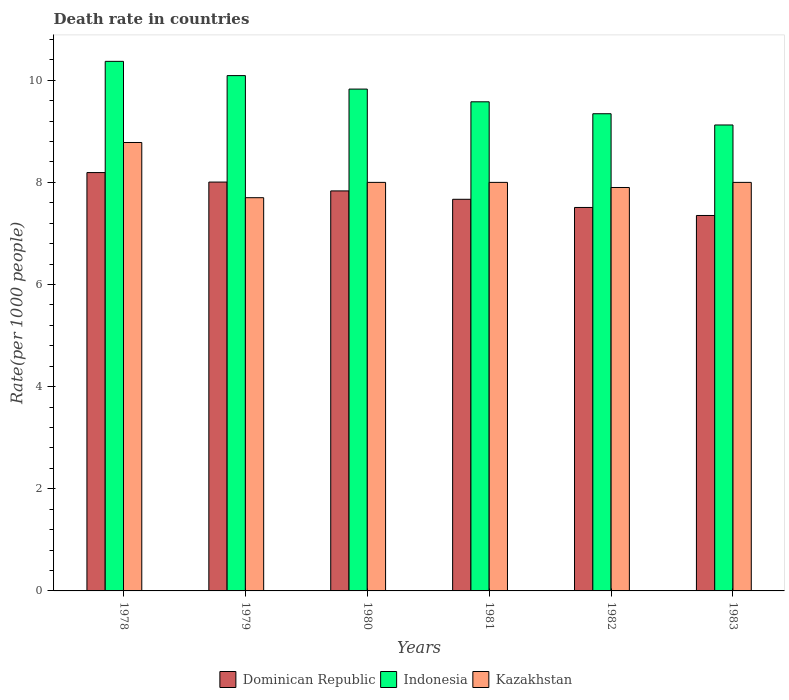How many different coloured bars are there?
Provide a short and direct response. 3. How many bars are there on the 2nd tick from the left?
Offer a very short reply. 3. What is the label of the 2nd group of bars from the left?
Provide a succinct answer. 1979. In how many cases, is the number of bars for a given year not equal to the number of legend labels?
Offer a terse response. 0. What is the death rate in Kazakhstan in 1980?
Offer a very short reply. 8. Across all years, what is the maximum death rate in Kazakhstan?
Make the answer very short. 8.78. In which year was the death rate in Indonesia maximum?
Your answer should be compact. 1978. What is the total death rate in Dominican Republic in the graph?
Your answer should be compact. 46.56. What is the difference between the death rate in Dominican Republic in 1980 and that in 1981?
Give a very brief answer. 0.16. What is the difference between the death rate in Dominican Republic in 1978 and the death rate in Kazakhstan in 1980?
Offer a terse response. 0.19. What is the average death rate in Dominican Republic per year?
Your response must be concise. 7.76. In the year 1981, what is the difference between the death rate in Dominican Republic and death rate in Indonesia?
Make the answer very short. -1.91. What is the ratio of the death rate in Kazakhstan in 1980 to that in 1981?
Make the answer very short. 1. Is the death rate in Dominican Republic in 1980 less than that in 1981?
Your response must be concise. No. Is the difference between the death rate in Dominican Republic in 1981 and 1983 greater than the difference between the death rate in Indonesia in 1981 and 1983?
Your response must be concise. No. What is the difference between the highest and the second highest death rate in Indonesia?
Provide a short and direct response. 0.28. What is the difference between the highest and the lowest death rate in Indonesia?
Provide a short and direct response. 1.25. What does the 3rd bar from the left in 1983 represents?
Offer a terse response. Kazakhstan. What does the 1st bar from the right in 1982 represents?
Your answer should be very brief. Kazakhstan. How many bars are there?
Your response must be concise. 18. Are all the bars in the graph horizontal?
Give a very brief answer. No. What is the difference between two consecutive major ticks on the Y-axis?
Ensure brevity in your answer.  2. Are the values on the major ticks of Y-axis written in scientific E-notation?
Your answer should be compact. No. Does the graph contain any zero values?
Ensure brevity in your answer.  No. Does the graph contain grids?
Give a very brief answer. No. How are the legend labels stacked?
Your response must be concise. Horizontal. What is the title of the graph?
Keep it short and to the point. Death rate in countries. What is the label or title of the Y-axis?
Give a very brief answer. Rate(per 1000 people). What is the Rate(per 1000 people) of Dominican Republic in 1978?
Ensure brevity in your answer.  8.19. What is the Rate(per 1000 people) in Indonesia in 1978?
Make the answer very short. 10.37. What is the Rate(per 1000 people) in Kazakhstan in 1978?
Provide a succinct answer. 8.78. What is the Rate(per 1000 people) in Dominican Republic in 1979?
Offer a terse response. 8.01. What is the Rate(per 1000 people) of Indonesia in 1979?
Offer a very short reply. 10.09. What is the Rate(per 1000 people) of Dominican Republic in 1980?
Offer a terse response. 7.83. What is the Rate(per 1000 people) in Indonesia in 1980?
Give a very brief answer. 9.83. What is the Rate(per 1000 people) of Dominican Republic in 1981?
Provide a succinct answer. 7.67. What is the Rate(per 1000 people) of Indonesia in 1981?
Offer a terse response. 9.58. What is the Rate(per 1000 people) of Dominican Republic in 1982?
Provide a short and direct response. 7.51. What is the Rate(per 1000 people) of Indonesia in 1982?
Your answer should be compact. 9.34. What is the Rate(per 1000 people) in Kazakhstan in 1982?
Your answer should be compact. 7.9. What is the Rate(per 1000 people) of Dominican Republic in 1983?
Provide a succinct answer. 7.35. What is the Rate(per 1000 people) of Indonesia in 1983?
Offer a very short reply. 9.12. Across all years, what is the maximum Rate(per 1000 people) in Dominican Republic?
Give a very brief answer. 8.19. Across all years, what is the maximum Rate(per 1000 people) of Indonesia?
Offer a terse response. 10.37. Across all years, what is the maximum Rate(per 1000 people) of Kazakhstan?
Your answer should be very brief. 8.78. Across all years, what is the minimum Rate(per 1000 people) of Dominican Republic?
Provide a short and direct response. 7.35. Across all years, what is the minimum Rate(per 1000 people) in Indonesia?
Your answer should be very brief. 9.12. What is the total Rate(per 1000 people) in Dominican Republic in the graph?
Provide a succinct answer. 46.56. What is the total Rate(per 1000 people) in Indonesia in the graph?
Provide a short and direct response. 58.33. What is the total Rate(per 1000 people) of Kazakhstan in the graph?
Provide a short and direct response. 48.38. What is the difference between the Rate(per 1000 people) of Dominican Republic in 1978 and that in 1979?
Give a very brief answer. 0.19. What is the difference between the Rate(per 1000 people) in Indonesia in 1978 and that in 1979?
Provide a short and direct response. 0.28. What is the difference between the Rate(per 1000 people) of Kazakhstan in 1978 and that in 1979?
Keep it short and to the point. 1.08. What is the difference between the Rate(per 1000 people) in Dominican Republic in 1978 and that in 1980?
Offer a terse response. 0.36. What is the difference between the Rate(per 1000 people) in Indonesia in 1978 and that in 1980?
Provide a succinct answer. 0.54. What is the difference between the Rate(per 1000 people) in Kazakhstan in 1978 and that in 1980?
Offer a terse response. 0.78. What is the difference between the Rate(per 1000 people) in Dominican Republic in 1978 and that in 1981?
Give a very brief answer. 0.52. What is the difference between the Rate(per 1000 people) of Indonesia in 1978 and that in 1981?
Your answer should be compact. 0.79. What is the difference between the Rate(per 1000 people) of Kazakhstan in 1978 and that in 1981?
Keep it short and to the point. 0.78. What is the difference between the Rate(per 1000 people) in Dominican Republic in 1978 and that in 1982?
Provide a short and direct response. 0.68. What is the difference between the Rate(per 1000 people) of Indonesia in 1978 and that in 1982?
Give a very brief answer. 1.03. What is the difference between the Rate(per 1000 people) in Kazakhstan in 1978 and that in 1982?
Keep it short and to the point. 0.88. What is the difference between the Rate(per 1000 people) of Dominican Republic in 1978 and that in 1983?
Keep it short and to the point. 0.84. What is the difference between the Rate(per 1000 people) of Indonesia in 1978 and that in 1983?
Provide a short and direct response. 1.25. What is the difference between the Rate(per 1000 people) of Kazakhstan in 1978 and that in 1983?
Offer a very short reply. 0.78. What is the difference between the Rate(per 1000 people) in Dominican Republic in 1979 and that in 1980?
Offer a terse response. 0.17. What is the difference between the Rate(per 1000 people) in Indonesia in 1979 and that in 1980?
Provide a short and direct response. 0.26. What is the difference between the Rate(per 1000 people) in Dominican Republic in 1979 and that in 1981?
Ensure brevity in your answer.  0.34. What is the difference between the Rate(per 1000 people) in Indonesia in 1979 and that in 1981?
Offer a terse response. 0.51. What is the difference between the Rate(per 1000 people) in Kazakhstan in 1979 and that in 1981?
Make the answer very short. -0.3. What is the difference between the Rate(per 1000 people) in Dominican Republic in 1979 and that in 1982?
Ensure brevity in your answer.  0.5. What is the difference between the Rate(per 1000 people) of Indonesia in 1979 and that in 1982?
Offer a very short reply. 0.75. What is the difference between the Rate(per 1000 people) of Dominican Republic in 1979 and that in 1983?
Make the answer very short. 0.65. What is the difference between the Rate(per 1000 people) of Indonesia in 1979 and that in 1983?
Your answer should be very brief. 0.97. What is the difference between the Rate(per 1000 people) in Kazakhstan in 1979 and that in 1983?
Offer a very short reply. -0.3. What is the difference between the Rate(per 1000 people) of Dominican Republic in 1980 and that in 1981?
Provide a short and direct response. 0.16. What is the difference between the Rate(per 1000 people) of Indonesia in 1980 and that in 1981?
Provide a succinct answer. 0.25. What is the difference between the Rate(per 1000 people) of Dominican Republic in 1980 and that in 1982?
Make the answer very short. 0.32. What is the difference between the Rate(per 1000 people) of Indonesia in 1980 and that in 1982?
Provide a succinct answer. 0.48. What is the difference between the Rate(per 1000 people) of Kazakhstan in 1980 and that in 1982?
Offer a very short reply. 0.1. What is the difference between the Rate(per 1000 people) of Dominican Republic in 1980 and that in 1983?
Offer a terse response. 0.48. What is the difference between the Rate(per 1000 people) of Indonesia in 1980 and that in 1983?
Ensure brevity in your answer.  0.7. What is the difference between the Rate(per 1000 people) of Kazakhstan in 1980 and that in 1983?
Offer a very short reply. 0. What is the difference between the Rate(per 1000 people) of Dominican Republic in 1981 and that in 1982?
Your answer should be compact. 0.16. What is the difference between the Rate(per 1000 people) in Indonesia in 1981 and that in 1982?
Give a very brief answer. 0.23. What is the difference between the Rate(per 1000 people) of Dominican Republic in 1981 and that in 1983?
Provide a short and direct response. 0.32. What is the difference between the Rate(per 1000 people) in Indonesia in 1981 and that in 1983?
Provide a short and direct response. 0.45. What is the difference between the Rate(per 1000 people) of Kazakhstan in 1981 and that in 1983?
Your answer should be very brief. 0. What is the difference between the Rate(per 1000 people) of Dominican Republic in 1982 and that in 1983?
Give a very brief answer. 0.16. What is the difference between the Rate(per 1000 people) of Indonesia in 1982 and that in 1983?
Provide a succinct answer. 0.22. What is the difference between the Rate(per 1000 people) in Kazakhstan in 1982 and that in 1983?
Offer a very short reply. -0.1. What is the difference between the Rate(per 1000 people) of Dominican Republic in 1978 and the Rate(per 1000 people) of Indonesia in 1979?
Ensure brevity in your answer.  -1.9. What is the difference between the Rate(per 1000 people) in Dominican Republic in 1978 and the Rate(per 1000 people) in Kazakhstan in 1979?
Your response must be concise. 0.49. What is the difference between the Rate(per 1000 people) of Indonesia in 1978 and the Rate(per 1000 people) of Kazakhstan in 1979?
Keep it short and to the point. 2.67. What is the difference between the Rate(per 1000 people) of Dominican Republic in 1978 and the Rate(per 1000 people) of Indonesia in 1980?
Your answer should be very brief. -1.64. What is the difference between the Rate(per 1000 people) of Dominican Republic in 1978 and the Rate(per 1000 people) of Kazakhstan in 1980?
Your response must be concise. 0.19. What is the difference between the Rate(per 1000 people) in Indonesia in 1978 and the Rate(per 1000 people) in Kazakhstan in 1980?
Give a very brief answer. 2.37. What is the difference between the Rate(per 1000 people) in Dominican Republic in 1978 and the Rate(per 1000 people) in Indonesia in 1981?
Provide a short and direct response. -1.39. What is the difference between the Rate(per 1000 people) in Dominican Republic in 1978 and the Rate(per 1000 people) in Kazakhstan in 1981?
Make the answer very short. 0.19. What is the difference between the Rate(per 1000 people) of Indonesia in 1978 and the Rate(per 1000 people) of Kazakhstan in 1981?
Keep it short and to the point. 2.37. What is the difference between the Rate(per 1000 people) in Dominican Republic in 1978 and the Rate(per 1000 people) in Indonesia in 1982?
Your response must be concise. -1.15. What is the difference between the Rate(per 1000 people) in Dominican Republic in 1978 and the Rate(per 1000 people) in Kazakhstan in 1982?
Provide a succinct answer. 0.29. What is the difference between the Rate(per 1000 people) in Indonesia in 1978 and the Rate(per 1000 people) in Kazakhstan in 1982?
Provide a short and direct response. 2.47. What is the difference between the Rate(per 1000 people) in Dominican Republic in 1978 and the Rate(per 1000 people) in Indonesia in 1983?
Offer a very short reply. -0.93. What is the difference between the Rate(per 1000 people) in Dominican Republic in 1978 and the Rate(per 1000 people) in Kazakhstan in 1983?
Provide a succinct answer. 0.19. What is the difference between the Rate(per 1000 people) in Indonesia in 1978 and the Rate(per 1000 people) in Kazakhstan in 1983?
Make the answer very short. 2.37. What is the difference between the Rate(per 1000 people) of Dominican Republic in 1979 and the Rate(per 1000 people) of Indonesia in 1980?
Provide a short and direct response. -1.82. What is the difference between the Rate(per 1000 people) of Dominican Republic in 1979 and the Rate(per 1000 people) of Kazakhstan in 1980?
Make the answer very short. 0.01. What is the difference between the Rate(per 1000 people) in Indonesia in 1979 and the Rate(per 1000 people) in Kazakhstan in 1980?
Offer a very short reply. 2.09. What is the difference between the Rate(per 1000 people) of Dominican Republic in 1979 and the Rate(per 1000 people) of Indonesia in 1981?
Your response must be concise. -1.57. What is the difference between the Rate(per 1000 people) in Dominican Republic in 1979 and the Rate(per 1000 people) in Kazakhstan in 1981?
Your response must be concise. 0.01. What is the difference between the Rate(per 1000 people) in Indonesia in 1979 and the Rate(per 1000 people) in Kazakhstan in 1981?
Your answer should be compact. 2.09. What is the difference between the Rate(per 1000 people) in Dominican Republic in 1979 and the Rate(per 1000 people) in Indonesia in 1982?
Provide a short and direct response. -1.34. What is the difference between the Rate(per 1000 people) in Dominican Republic in 1979 and the Rate(per 1000 people) in Kazakhstan in 1982?
Ensure brevity in your answer.  0.11. What is the difference between the Rate(per 1000 people) in Indonesia in 1979 and the Rate(per 1000 people) in Kazakhstan in 1982?
Your answer should be very brief. 2.19. What is the difference between the Rate(per 1000 people) in Dominican Republic in 1979 and the Rate(per 1000 people) in Indonesia in 1983?
Provide a succinct answer. -1.12. What is the difference between the Rate(per 1000 people) in Dominican Republic in 1979 and the Rate(per 1000 people) in Kazakhstan in 1983?
Keep it short and to the point. 0.01. What is the difference between the Rate(per 1000 people) in Indonesia in 1979 and the Rate(per 1000 people) in Kazakhstan in 1983?
Your answer should be compact. 2.09. What is the difference between the Rate(per 1000 people) in Dominican Republic in 1980 and the Rate(per 1000 people) in Indonesia in 1981?
Offer a terse response. -1.75. What is the difference between the Rate(per 1000 people) in Dominican Republic in 1980 and the Rate(per 1000 people) in Kazakhstan in 1981?
Offer a very short reply. -0.17. What is the difference between the Rate(per 1000 people) of Indonesia in 1980 and the Rate(per 1000 people) of Kazakhstan in 1981?
Keep it short and to the point. 1.83. What is the difference between the Rate(per 1000 people) of Dominican Republic in 1980 and the Rate(per 1000 people) of Indonesia in 1982?
Give a very brief answer. -1.51. What is the difference between the Rate(per 1000 people) in Dominican Republic in 1980 and the Rate(per 1000 people) in Kazakhstan in 1982?
Provide a short and direct response. -0.07. What is the difference between the Rate(per 1000 people) in Indonesia in 1980 and the Rate(per 1000 people) in Kazakhstan in 1982?
Your answer should be compact. 1.93. What is the difference between the Rate(per 1000 people) in Dominican Republic in 1980 and the Rate(per 1000 people) in Indonesia in 1983?
Provide a short and direct response. -1.29. What is the difference between the Rate(per 1000 people) in Dominican Republic in 1980 and the Rate(per 1000 people) in Kazakhstan in 1983?
Provide a short and direct response. -0.17. What is the difference between the Rate(per 1000 people) of Indonesia in 1980 and the Rate(per 1000 people) of Kazakhstan in 1983?
Give a very brief answer. 1.83. What is the difference between the Rate(per 1000 people) of Dominican Republic in 1981 and the Rate(per 1000 people) of Indonesia in 1982?
Provide a short and direct response. -1.68. What is the difference between the Rate(per 1000 people) of Dominican Republic in 1981 and the Rate(per 1000 people) of Kazakhstan in 1982?
Your response must be concise. -0.23. What is the difference between the Rate(per 1000 people) in Indonesia in 1981 and the Rate(per 1000 people) in Kazakhstan in 1982?
Provide a short and direct response. 1.68. What is the difference between the Rate(per 1000 people) of Dominican Republic in 1981 and the Rate(per 1000 people) of Indonesia in 1983?
Make the answer very short. -1.46. What is the difference between the Rate(per 1000 people) of Dominican Republic in 1981 and the Rate(per 1000 people) of Kazakhstan in 1983?
Give a very brief answer. -0.33. What is the difference between the Rate(per 1000 people) in Indonesia in 1981 and the Rate(per 1000 people) in Kazakhstan in 1983?
Provide a succinct answer. 1.58. What is the difference between the Rate(per 1000 people) of Dominican Republic in 1982 and the Rate(per 1000 people) of Indonesia in 1983?
Ensure brevity in your answer.  -1.61. What is the difference between the Rate(per 1000 people) of Dominican Republic in 1982 and the Rate(per 1000 people) of Kazakhstan in 1983?
Your answer should be compact. -0.49. What is the difference between the Rate(per 1000 people) of Indonesia in 1982 and the Rate(per 1000 people) of Kazakhstan in 1983?
Make the answer very short. 1.34. What is the average Rate(per 1000 people) of Dominican Republic per year?
Your response must be concise. 7.76. What is the average Rate(per 1000 people) in Indonesia per year?
Ensure brevity in your answer.  9.72. What is the average Rate(per 1000 people) in Kazakhstan per year?
Ensure brevity in your answer.  8.06. In the year 1978, what is the difference between the Rate(per 1000 people) in Dominican Republic and Rate(per 1000 people) in Indonesia?
Make the answer very short. -2.18. In the year 1978, what is the difference between the Rate(per 1000 people) of Dominican Republic and Rate(per 1000 people) of Kazakhstan?
Give a very brief answer. -0.59. In the year 1978, what is the difference between the Rate(per 1000 people) in Indonesia and Rate(per 1000 people) in Kazakhstan?
Provide a short and direct response. 1.59. In the year 1979, what is the difference between the Rate(per 1000 people) in Dominican Republic and Rate(per 1000 people) in Indonesia?
Provide a short and direct response. -2.08. In the year 1979, what is the difference between the Rate(per 1000 people) in Dominican Republic and Rate(per 1000 people) in Kazakhstan?
Ensure brevity in your answer.  0.31. In the year 1979, what is the difference between the Rate(per 1000 people) in Indonesia and Rate(per 1000 people) in Kazakhstan?
Your response must be concise. 2.39. In the year 1980, what is the difference between the Rate(per 1000 people) in Dominican Republic and Rate(per 1000 people) in Indonesia?
Your answer should be compact. -1.99. In the year 1980, what is the difference between the Rate(per 1000 people) of Dominican Republic and Rate(per 1000 people) of Kazakhstan?
Your answer should be compact. -0.17. In the year 1980, what is the difference between the Rate(per 1000 people) in Indonesia and Rate(per 1000 people) in Kazakhstan?
Offer a terse response. 1.83. In the year 1981, what is the difference between the Rate(per 1000 people) of Dominican Republic and Rate(per 1000 people) of Indonesia?
Your response must be concise. -1.91. In the year 1981, what is the difference between the Rate(per 1000 people) in Dominican Republic and Rate(per 1000 people) in Kazakhstan?
Provide a succinct answer. -0.33. In the year 1981, what is the difference between the Rate(per 1000 people) in Indonesia and Rate(per 1000 people) in Kazakhstan?
Ensure brevity in your answer.  1.58. In the year 1982, what is the difference between the Rate(per 1000 people) in Dominican Republic and Rate(per 1000 people) in Indonesia?
Your answer should be compact. -1.83. In the year 1982, what is the difference between the Rate(per 1000 people) in Dominican Republic and Rate(per 1000 people) in Kazakhstan?
Give a very brief answer. -0.39. In the year 1982, what is the difference between the Rate(per 1000 people) of Indonesia and Rate(per 1000 people) of Kazakhstan?
Your answer should be compact. 1.44. In the year 1983, what is the difference between the Rate(per 1000 people) in Dominican Republic and Rate(per 1000 people) in Indonesia?
Your answer should be very brief. -1.77. In the year 1983, what is the difference between the Rate(per 1000 people) of Dominican Republic and Rate(per 1000 people) of Kazakhstan?
Provide a short and direct response. -0.65. In the year 1983, what is the difference between the Rate(per 1000 people) in Indonesia and Rate(per 1000 people) in Kazakhstan?
Your answer should be compact. 1.12. What is the ratio of the Rate(per 1000 people) in Dominican Republic in 1978 to that in 1979?
Provide a succinct answer. 1.02. What is the ratio of the Rate(per 1000 people) of Indonesia in 1978 to that in 1979?
Keep it short and to the point. 1.03. What is the ratio of the Rate(per 1000 people) in Kazakhstan in 1978 to that in 1979?
Ensure brevity in your answer.  1.14. What is the ratio of the Rate(per 1000 people) of Dominican Republic in 1978 to that in 1980?
Provide a succinct answer. 1.05. What is the ratio of the Rate(per 1000 people) in Indonesia in 1978 to that in 1980?
Offer a terse response. 1.06. What is the ratio of the Rate(per 1000 people) in Kazakhstan in 1978 to that in 1980?
Make the answer very short. 1.1. What is the ratio of the Rate(per 1000 people) of Dominican Republic in 1978 to that in 1981?
Provide a succinct answer. 1.07. What is the ratio of the Rate(per 1000 people) in Indonesia in 1978 to that in 1981?
Make the answer very short. 1.08. What is the ratio of the Rate(per 1000 people) of Kazakhstan in 1978 to that in 1981?
Your answer should be compact. 1.1. What is the ratio of the Rate(per 1000 people) of Dominican Republic in 1978 to that in 1982?
Keep it short and to the point. 1.09. What is the ratio of the Rate(per 1000 people) of Indonesia in 1978 to that in 1982?
Give a very brief answer. 1.11. What is the ratio of the Rate(per 1000 people) in Kazakhstan in 1978 to that in 1982?
Offer a very short reply. 1.11. What is the ratio of the Rate(per 1000 people) of Dominican Republic in 1978 to that in 1983?
Provide a succinct answer. 1.11. What is the ratio of the Rate(per 1000 people) of Indonesia in 1978 to that in 1983?
Your response must be concise. 1.14. What is the ratio of the Rate(per 1000 people) in Kazakhstan in 1978 to that in 1983?
Offer a very short reply. 1.1. What is the ratio of the Rate(per 1000 people) of Dominican Republic in 1979 to that in 1980?
Make the answer very short. 1.02. What is the ratio of the Rate(per 1000 people) in Indonesia in 1979 to that in 1980?
Give a very brief answer. 1.03. What is the ratio of the Rate(per 1000 people) in Kazakhstan in 1979 to that in 1980?
Provide a short and direct response. 0.96. What is the ratio of the Rate(per 1000 people) of Dominican Republic in 1979 to that in 1981?
Make the answer very short. 1.04. What is the ratio of the Rate(per 1000 people) of Indonesia in 1979 to that in 1981?
Offer a terse response. 1.05. What is the ratio of the Rate(per 1000 people) of Kazakhstan in 1979 to that in 1981?
Provide a short and direct response. 0.96. What is the ratio of the Rate(per 1000 people) in Dominican Republic in 1979 to that in 1982?
Offer a terse response. 1.07. What is the ratio of the Rate(per 1000 people) in Indonesia in 1979 to that in 1982?
Your response must be concise. 1.08. What is the ratio of the Rate(per 1000 people) of Kazakhstan in 1979 to that in 1982?
Offer a very short reply. 0.97. What is the ratio of the Rate(per 1000 people) in Dominican Republic in 1979 to that in 1983?
Your answer should be compact. 1.09. What is the ratio of the Rate(per 1000 people) of Indonesia in 1979 to that in 1983?
Offer a terse response. 1.11. What is the ratio of the Rate(per 1000 people) in Kazakhstan in 1979 to that in 1983?
Your answer should be compact. 0.96. What is the ratio of the Rate(per 1000 people) in Dominican Republic in 1980 to that in 1981?
Provide a succinct answer. 1.02. What is the ratio of the Rate(per 1000 people) in Indonesia in 1980 to that in 1981?
Keep it short and to the point. 1.03. What is the ratio of the Rate(per 1000 people) in Dominican Republic in 1980 to that in 1982?
Give a very brief answer. 1.04. What is the ratio of the Rate(per 1000 people) in Indonesia in 1980 to that in 1982?
Offer a very short reply. 1.05. What is the ratio of the Rate(per 1000 people) in Kazakhstan in 1980 to that in 1982?
Provide a succinct answer. 1.01. What is the ratio of the Rate(per 1000 people) of Dominican Republic in 1980 to that in 1983?
Provide a succinct answer. 1.07. What is the ratio of the Rate(per 1000 people) of Indonesia in 1980 to that in 1983?
Give a very brief answer. 1.08. What is the ratio of the Rate(per 1000 people) of Dominican Republic in 1981 to that in 1982?
Offer a very short reply. 1.02. What is the ratio of the Rate(per 1000 people) of Kazakhstan in 1981 to that in 1982?
Your answer should be very brief. 1.01. What is the ratio of the Rate(per 1000 people) in Dominican Republic in 1981 to that in 1983?
Your answer should be compact. 1.04. What is the ratio of the Rate(per 1000 people) of Indonesia in 1981 to that in 1983?
Offer a terse response. 1.05. What is the ratio of the Rate(per 1000 people) of Dominican Republic in 1982 to that in 1983?
Keep it short and to the point. 1.02. What is the ratio of the Rate(per 1000 people) of Indonesia in 1982 to that in 1983?
Your answer should be very brief. 1.02. What is the ratio of the Rate(per 1000 people) of Kazakhstan in 1982 to that in 1983?
Keep it short and to the point. 0.99. What is the difference between the highest and the second highest Rate(per 1000 people) of Dominican Republic?
Ensure brevity in your answer.  0.19. What is the difference between the highest and the second highest Rate(per 1000 people) in Indonesia?
Your response must be concise. 0.28. What is the difference between the highest and the second highest Rate(per 1000 people) of Kazakhstan?
Offer a terse response. 0.78. What is the difference between the highest and the lowest Rate(per 1000 people) of Dominican Republic?
Offer a terse response. 0.84. What is the difference between the highest and the lowest Rate(per 1000 people) of Indonesia?
Keep it short and to the point. 1.25. What is the difference between the highest and the lowest Rate(per 1000 people) in Kazakhstan?
Give a very brief answer. 1.08. 